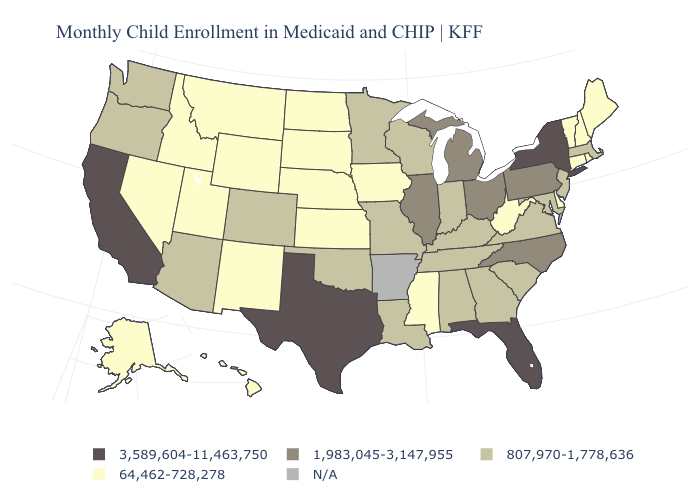What is the lowest value in states that border Idaho?
Quick response, please. 64,462-728,278. Which states have the lowest value in the MidWest?
Quick response, please. Iowa, Kansas, Nebraska, North Dakota, South Dakota. Among the states that border Michigan , does Ohio have the highest value?
Quick response, please. Yes. Name the states that have a value in the range N/A?
Concise answer only. Arkansas. Does Kentucky have the highest value in the USA?
Concise answer only. No. Name the states that have a value in the range 64,462-728,278?
Keep it brief. Alaska, Connecticut, Delaware, Hawaii, Idaho, Iowa, Kansas, Maine, Mississippi, Montana, Nebraska, Nevada, New Hampshire, New Mexico, North Dakota, Rhode Island, South Dakota, Utah, Vermont, West Virginia, Wyoming. Name the states that have a value in the range 64,462-728,278?
Answer briefly. Alaska, Connecticut, Delaware, Hawaii, Idaho, Iowa, Kansas, Maine, Mississippi, Montana, Nebraska, Nevada, New Hampshire, New Mexico, North Dakota, Rhode Island, South Dakota, Utah, Vermont, West Virginia, Wyoming. What is the lowest value in the USA?
Give a very brief answer. 64,462-728,278. What is the value of Washington?
Be succinct. 807,970-1,778,636. Among the states that border California , which have the lowest value?
Write a very short answer. Nevada. Name the states that have a value in the range 807,970-1,778,636?
Answer briefly. Alabama, Arizona, Colorado, Georgia, Indiana, Kentucky, Louisiana, Maryland, Massachusetts, Minnesota, Missouri, New Jersey, Oklahoma, Oregon, South Carolina, Tennessee, Virginia, Washington, Wisconsin. Among the states that border Delaware , which have the highest value?
Answer briefly. Pennsylvania. What is the value of Georgia?
Be succinct. 807,970-1,778,636. What is the value of Rhode Island?
Keep it brief. 64,462-728,278. What is the lowest value in the USA?
Give a very brief answer. 64,462-728,278. 